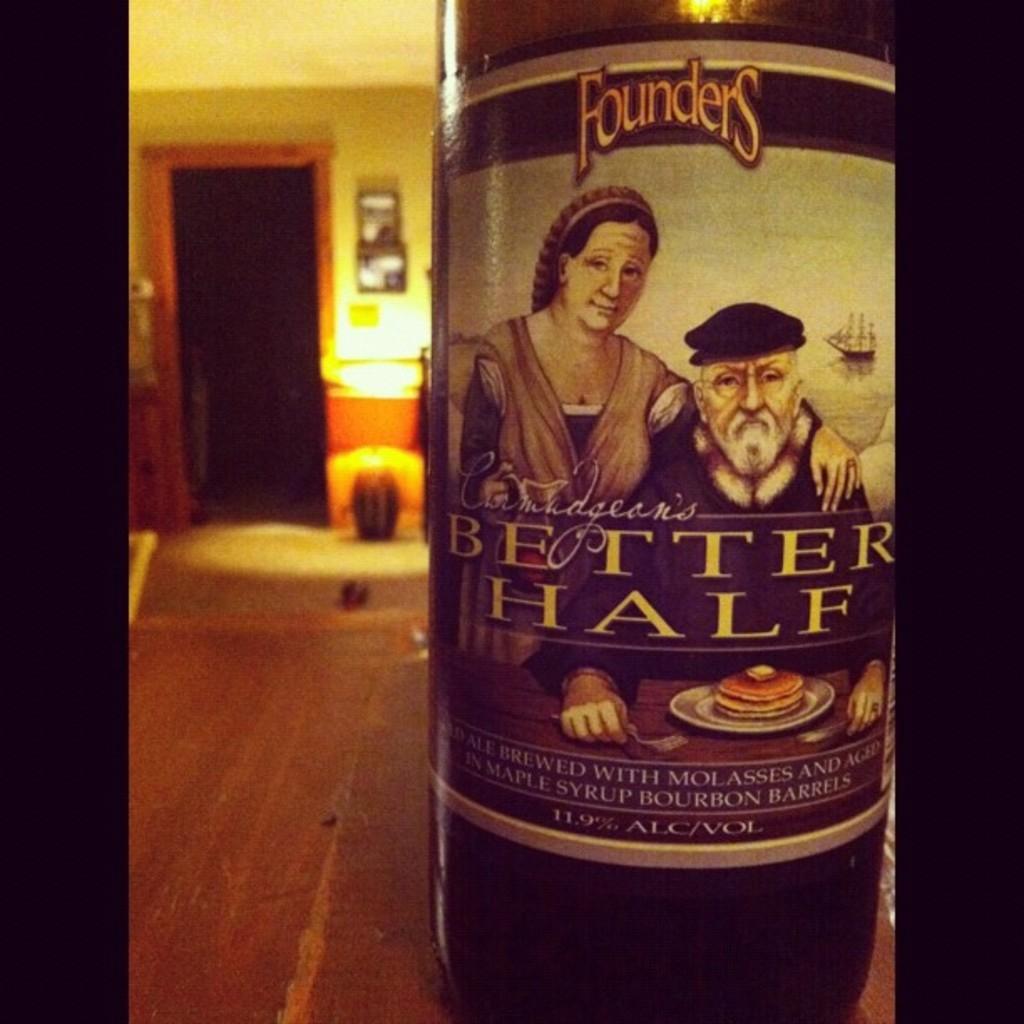Please provide a concise description of this image. Here we can see a bottle. On this bottle there are two persons and a plate with food. In the background we can see a wall and frames. 